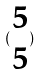<formula> <loc_0><loc_0><loc_500><loc_500>( \begin{matrix} 5 \\ 5 \end{matrix} )</formula> 